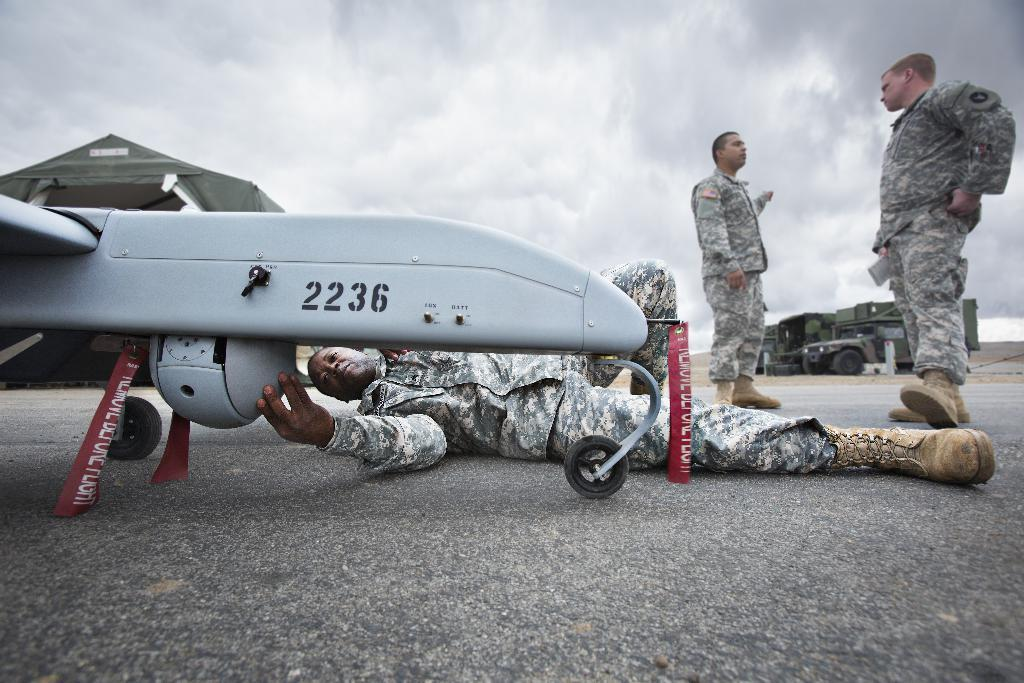<image>
Describe the image concisely. Army soldiers are fixing a piece of equipment with a black knob on the side and numbers 2236. 